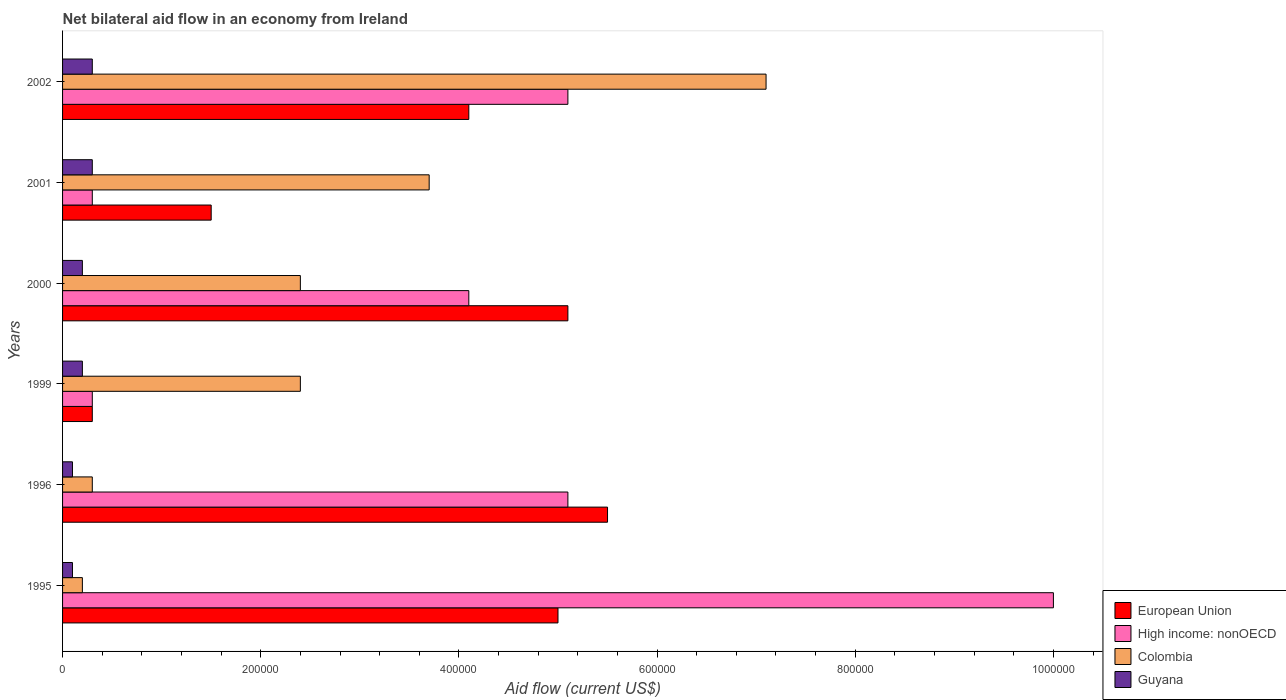How many different coloured bars are there?
Keep it short and to the point. 4. How many groups of bars are there?
Provide a succinct answer. 6. Are the number of bars per tick equal to the number of legend labels?
Ensure brevity in your answer.  Yes. Are the number of bars on each tick of the Y-axis equal?
Make the answer very short. Yes. How many bars are there on the 1st tick from the top?
Offer a terse response. 4. What is the label of the 3rd group of bars from the top?
Make the answer very short. 2000. In how many cases, is the number of bars for a given year not equal to the number of legend labels?
Your answer should be compact. 0. What is the net bilateral aid flow in Colombia in 1995?
Your answer should be very brief. 2.00e+04. Across all years, what is the maximum net bilateral aid flow in European Union?
Make the answer very short. 5.50e+05. Across all years, what is the minimum net bilateral aid flow in Guyana?
Keep it short and to the point. 10000. What is the total net bilateral aid flow in Colombia in the graph?
Your response must be concise. 1.61e+06. What is the difference between the net bilateral aid flow in European Union in 1996 and the net bilateral aid flow in High income: nonOECD in 1995?
Make the answer very short. -4.50e+05. What is the average net bilateral aid flow in European Union per year?
Your answer should be compact. 3.58e+05. In the year 1996, what is the difference between the net bilateral aid flow in Colombia and net bilateral aid flow in European Union?
Ensure brevity in your answer.  -5.20e+05. What is the ratio of the net bilateral aid flow in Guyana in 1999 to that in 2000?
Your response must be concise. 1. Is the difference between the net bilateral aid flow in Colombia in 1995 and 1999 greater than the difference between the net bilateral aid flow in European Union in 1995 and 1999?
Your response must be concise. No. What is the difference between the highest and the second highest net bilateral aid flow in European Union?
Give a very brief answer. 4.00e+04. What is the difference between the highest and the lowest net bilateral aid flow in Guyana?
Give a very brief answer. 2.00e+04. Is the sum of the net bilateral aid flow in European Union in 2000 and 2002 greater than the maximum net bilateral aid flow in High income: nonOECD across all years?
Give a very brief answer. No. Is it the case that in every year, the sum of the net bilateral aid flow in High income: nonOECD and net bilateral aid flow in Colombia is greater than the sum of net bilateral aid flow in European Union and net bilateral aid flow in Guyana?
Provide a short and direct response. No. What does the 4th bar from the bottom in 2002 represents?
Your response must be concise. Guyana. How many bars are there?
Your response must be concise. 24. Are all the bars in the graph horizontal?
Keep it short and to the point. Yes. How many years are there in the graph?
Ensure brevity in your answer.  6. What is the difference between two consecutive major ticks on the X-axis?
Offer a terse response. 2.00e+05. Does the graph contain any zero values?
Your answer should be very brief. No. Does the graph contain grids?
Provide a short and direct response. No. Where does the legend appear in the graph?
Your answer should be very brief. Bottom right. How many legend labels are there?
Give a very brief answer. 4. How are the legend labels stacked?
Make the answer very short. Vertical. What is the title of the graph?
Keep it short and to the point. Net bilateral aid flow in an economy from Ireland. Does "Cyprus" appear as one of the legend labels in the graph?
Make the answer very short. No. What is the label or title of the X-axis?
Keep it short and to the point. Aid flow (current US$). What is the label or title of the Y-axis?
Provide a succinct answer. Years. What is the Aid flow (current US$) in High income: nonOECD in 1995?
Keep it short and to the point. 1.00e+06. What is the Aid flow (current US$) of European Union in 1996?
Give a very brief answer. 5.50e+05. What is the Aid flow (current US$) of High income: nonOECD in 1996?
Make the answer very short. 5.10e+05. What is the Aid flow (current US$) in Colombia in 1996?
Offer a terse response. 3.00e+04. What is the Aid flow (current US$) of Guyana in 1996?
Offer a terse response. 10000. What is the Aid flow (current US$) in High income: nonOECD in 1999?
Your answer should be very brief. 3.00e+04. What is the Aid flow (current US$) in Colombia in 1999?
Keep it short and to the point. 2.40e+05. What is the Aid flow (current US$) of European Union in 2000?
Make the answer very short. 5.10e+05. What is the Aid flow (current US$) of European Union in 2001?
Offer a very short reply. 1.50e+05. What is the Aid flow (current US$) in High income: nonOECD in 2001?
Offer a terse response. 3.00e+04. What is the Aid flow (current US$) in Colombia in 2001?
Your answer should be compact. 3.70e+05. What is the Aid flow (current US$) of Guyana in 2001?
Make the answer very short. 3.00e+04. What is the Aid flow (current US$) of European Union in 2002?
Provide a succinct answer. 4.10e+05. What is the Aid flow (current US$) of High income: nonOECD in 2002?
Your answer should be compact. 5.10e+05. What is the Aid flow (current US$) of Colombia in 2002?
Provide a succinct answer. 7.10e+05. Across all years, what is the maximum Aid flow (current US$) in Colombia?
Give a very brief answer. 7.10e+05. Across all years, what is the maximum Aid flow (current US$) in Guyana?
Keep it short and to the point. 3.00e+04. Across all years, what is the minimum Aid flow (current US$) in Colombia?
Ensure brevity in your answer.  2.00e+04. Across all years, what is the minimum Aid flow (current US$) of Guyana?
Make the answer very short. 10000. What is the total Aid flow (current US$) in European Union in the graph?
Your answer should be very brief. 2.15e+06. What is the total Aid flow (current US$) of High income: nonOECD in the graph?
Give a very brief answer. 2.49e+06. What is the total Aid flow (current US$) in Colombia in the graph?
Your answer should be compact. 1.61e+06. What is the difference between the Aid flow (current US$) in European Union in 1995 and that in 1996?
Offer a terse response. -5.00e+04. What is the difference between the Aid flow (current US$) of Colombia in 1995 and that in 1996?
Your answer should be very brief. -10000. What is the difference between the Aid flow (current US$) of European Union in 1995 and that in 1999?
Offer a terse response. 4.70e+05. What is the difference between the Aid flow (current US$) of High income: nonOECD in 1995 and that in 1999?
Your answer should be very brief. 9.70e+05. What is the difference between the Aid flow (current US$) in Colombia in 1995 and that in 1999?
Make the answer very short. -2.20e+05. What is the difference between the Aid flow (current US$) of Guyana in 1995 and that in 1999?
Provide a succinct answer. -10000. What is the difference between the Aid flow (current US$) of High income: nonOECD in 1995 and that in 2000?
Your answer should be compact. 5.90e+05. What is the difference between the Aid flow (current US$) of Colombia in 1995 and that in 2000?
Make the answer very short. -2.20e+05. What is the difference between the Aid flow (current US$) in High income: nonOECD in 1995 and that in 2001?
Provide a short and direct response. 9.70e+05. What is the difference between the Aid flow (current US$) in Colombia in 1995 and that in 2001?
Keep it short and to the point. -3.50e+05. What is the difference between the Aid flow (current US$) of Guyana in 1995 and that in 2001?
Make the answer very short. -2.00e+04. What is the difference between the Aid flow (current US$) of European Union in 1995 and that in 2002?
Your answer should be very brief. 9.00e+04. What is the difference between the Aid flow (current US$) in High income: nonOECD in 1995 and that in 2002?
Provide a succinct answer. 4.90e+05. What is the difference between the Aid flow (current US$) of Colombia in 1995 and that in 2002?
Make the answer very short. -6.90e+05. What is the difference between the Aid flow (current US$) of Guyana in 1995 and that in 2002?
Your answer should be very brief. -2.00e+04. What is the difference between the Aid flow (current US$) of European Union in 1996 and that in 1999?
Give a very brief answer. 5.20e+05. What is the difference between the Aid flow (current US$) in European Union in 1996 and that in 2000?
Ensure brevity in your answer.  4.00e+04. What is the difference between the Aid flow (current US$) of High income: nonOECD in 1996 and that in 2000?
Offer a terse response. 1.00e+05. What is the difference between the Aid flow (current US$) of European Union in 1996 and that in 2001?
Your answer should be compact. 4.00e+05. What is the difference between the Aid flow (current US$) of High income: nonOECD in 1996 and that in 2001?
Provide a succinct answer. 4.80e+05. What is the difference between the Aid flow (current US$) in Colombia in 1996 and that in 2001?
Offer a terse response. -3.40e+05. What is the difference between the Aid flow (current US$) in European Union in 1996 and that in 2002?
Provide a succinct answer. 1.40e+05. What is the difference between the Aid flow (current US$) of Colombia in 1996 and that in 2002?
Give a very brief answer. -6.80e+05. What is the difference between the Aid flow (current US$) in European Union in 1999 and that in 2000?
Offer a very short reply. -4.80e+05. What is the difference between the Aid flow (current US$) of High income: nonOECD in 1999 and that in 2000?
Offer a very short reply. -3.80e+05. What is the difference between the Aid flow (current US$) of Guyana in 1999 and that in 2000?
Ensure brevity in your answer.  0. What is the difference between the Aid flow (current US$) of Colombia in 1999 and that in 2001?
Make the answer very short. -1.30e+05. What is the difference between the Aid flow (current US$) in European Union in 1999 and that in 2002?
Provide a short and direct response. -3.80e+05. What is the difference between the Aid flow (current US$) of High income: nonOECD in 1999 and that in 2002?
Ensure brevity in your answer.  -4.80e+05. What is the difference between the Aid flow (current US$) in Colombia in 1999 and that in 2002?
Offer a terse response. -4.70e+05. What is the difference between the Aid flow (current US$) in Guyana in 1999 and that in 2002?
Give a very brief answer. -10000. What is the difference between the Aid flow (current US$) in European Union in 2000 and that in 2001?
Your answer should be compact. 3.60e+05. What is the difference between the Aid flow (current US$) in European Union in 2000 and that in 2002?
Your answer should be compact. 1.00e+05. What is the difference between the Aid flow (current US$) in Colombia in 2000 and that in 2002?
Your response must be concise. -4.70e+05. What is the difference between the Aid flow (current US$) of European Union in 2001 and that in 2002?
Provide a short and direct response. -2.60e+05. What is the difference between the Aid flow (current US$) of High income: nonOECD in 2001 and that in 2002?
Offer a terse response. -4.80e+05. What is the difference between the Aid flow (current US$) of European Union in 1995 and the Aid flow (current US$) of High income: nonOECD in 1996?
Keep it short and to the point. -10000. What is the difference between the Aid flow (current US$) of High income: nonOECD in 1995 and the Aid flow (current US$) of Colombia in 1996?
Your response must be concise. 9.70e+05. What is the difference between the Aid flow (current US$) in High income: nonOECD in 1995 and the Aid flow (current US$) in Guyana in 1996?
Offer a terse response. 9.90e+05. What is the difference between the Aid flow (current US$) of European Union in 1995 and the Aid flow (current US$) of High income: nonOECD in 1999?
Give a very brief answer. 4.70e+05. What is the difference between the Aid flow (current US$) in High income: nonOECD in 1995 and the Aid flow (current US$) in Colombia in 1999?
Provide a succinct answer. 7.60e+05. What is the difference between the Aid flow (current US$) in High income: nonOECD in 1995 and the Aid flow (current US$) in Guyana in 1999?
Give a very brief answer. 9.80e+05. What is the difference between the Aid flow (current US$) of Colombia in 1995 and the Aid flow (current US$) of Guyana in 1999?
Your answer should be very brief. 0. What is the difference between the Aid flow (current US$) of European Union in 1995 and the Aid flow (current US$) of High income: nonOECD in 2000?
Provide a succinct answer. 9.00e+04. What is the difference between the Aid flow (current US$) of High income: nonOECD in 1995 and the Aid flow (current US$) of Colombia in 2000?
Keep it short and to the point. 7.60e+05. What is the difference between the Aid flow (current US$) in High income: nonOECD in 1995 and the Aid flow (current US$) in Guyana in 2000?
Give a very brief answer. 9.80e+05. What is the difference between the Aid flow (current US$) in European Union in 1995 and the Aid flow (current US$) in Colombia in 2001?
Give a very brief answer. 1.30e+05. What is the difference between the Aid flow (current US$) in High income: nonOECD in 1995 and the Aid flow (current US$) in Colombia in 2001?
Offer a terse response. 6.30e+05. What is the difference between the Aid flow (current US$) in High income: nonOECD in 1995 and the Aid flow (current US$) in Guyana in 2001?
Ensure brevity in your answer.  9.70e+05. What is the difference between the Aid flow (current US$) in Colombia in 1995 and the Aid flow (current US$) in Guyana in 2001?
Keep it short and to the point. -10000. What is the difference between the Aid flow (current US$) of European Union in 1995 and the Aid flow (current US$) of Colombia in 2002?
Your answer should be compact. -2.10e+05. What is the difference between the Aid flow (current US$) in European Union in 1995 and the Aid flow (current US$) in Guyana in 2002?
Your answer should be very brief. 4.70e+05. What is the difference between the Aid flow (current US$) of High income: nonOECD in 1995 and the Aid flow (current US$) of Colombia in 2002?
Your answer should be very brief. 2.90e+05. What is the difference between the Aid flow (current US$) of High income: nonOECD in 1995 and the Aid flow (current US$) of Guyana in 2002?
Give a very brief answer. 9.70e+05. What is the difference between the Aid flow (current US$) in Colombia in 1995 and the Aid flow (current US$) in Guyana in 2002?
Ensure brevity in your answer.  -10000. What is the difference between the Aid flow (current US$) of European Union in 1996 and the Aid flow (current US$) of High income: nonOECD in 1999?
Provide a short and direct response. 5.20e+05. What is the difference between the Aid flow (current US$) of European Union in 1996 and the Aid flow (current US$) of Guyana in 1999?
Ensure brevity in your answer.  5.30e+05. What is the difference between the Aid flow (current US$) of High income: nonOECD in 1996 and the Aid flow (current US$) of Guyana in 1999?
Your answer should be very brief. 4.90e+05. What is the difference between the Aid flow (current US$) in European Union in 1996 and the Aid flow (current US$) in High income: nonOECD in 2000?
Ensure brevity in your answer.  1.40e+05. What is the difference between the Aid flow (current US$) of European Union in 1996 and the Aid flow (current US$) of Colombia in 2000?
Make the answer very short. 3.10e+05. What is the difference between the Aid flow (current US$) of European Union in 1996 and the Aid flow (current US$) of Guyana in 2000?
Your response must be concise. 5.30e+05. What is the difference between the Aid flow (current US$) in High income: nonOECD in 1996 and the Aid flow (current US$) in Guyana in 2000?
Your answer should be very brief. 4.90e+05. What is the difference between the Aid flow (current US$) in European Union in 1996 and the Aid flow (current US$) in High income: nonOECD in 2001?
Keep it short and to the point. 5.20e+05. What is the difference between the Aid flow (current US$) in European Union in 1996 and the Aid flow (current US$) in Guyana in 2001?
Offer a terse response. 5.20e+05. What is the difference between the Aid flow (current US$) in High income: nonOECD in 1996 and the Aid flow (current US$) in Guyana in 2001?
Your answer should be very brief. 4.80e+05. What is the difference between the Aid flow (current US$) of Colombia in 1996 and the Aid flow (current US$) of Guyana in 2001?
Your answer should be compact. 0. What is the difference between the Aid flow (current US$) in European Union in 1996 and the Aid flow (current US$) in High income: nonOECD in 2002?
Ensure brevity in your answer.  4.00e+04. What is the difference between the Aid flow (current US$) of European Union in 1996 and the Aid flow (current US$) of Guyana in 2002?
Provide a succinct answer. 5.20e+05. What is the difference between the Aid flow (current US$) of High income: nonOECD in 1996 and the Aid flow (current US$) of Guyana in 2002?
Provide a succinct answer. 4.80e+05. What is the difference between the Aid flow (current US$) of European Union in 1999 and the Aid flow (current US$) of High income: nonOECD in 2000?
Offer a terse response. -3.80e+05. What is the difference between the Aid flow (current US$) in European Union in 1999 and the Aid flow (current US$) in Guyana in 2000?
Your answer should be compact. 10000. What is the difference between the Aid flow (current US$) in High income: nonOECD in 1999 and the Aid flow (current US$) in Colombia in 2000?
Keep it short and to the point. -2.10e+05. What is the difference between the Aid flow (current US$) in High income: nonOECD in 1999 and the Aid flow (current US$) in Guyana in 2000?
Provide a succinct answer. 10000. What is the difference between the Aid flow (current US$) in High income: nonOECD in 1999 and the Aid flow (current US$) in Colombia in 2001?
Give a very brief answer. -3.40e+05. What is the difference between the Aid flow (current US$) of High income: nonOECD in 1999 and the Aid flow (current US$) of Guyana in 2001?
Ensure brevity in your answer.  0. What is the difference between the Aid flow (current US$) in Colombia in 1999 and the Aid flow (current US$) in Guyana in 2001?
Give a very brief answer. 2.10e+05. What is the difference between the Aid flow (current US$) of European Union in 1999 and the Aid flow (current US$) of High income: nonOECD in 2002?
Your response must be concise. -4.80e+05. What is the difference between the Aid flow (current US$) in European Union in 1999 and the Aid flow (current US$) in Colombia in 2002?
Your answer should be compact. -6.80e+05. What is the difference between the Aid flow (current US$) in High income: nonOECD in 1999 and the Aid flow (current US$) in Colombia in 2002?
Offer a very short reply. -6.80e+05. What is the difference between the Aid flow (current US$) in High income: nonOECD in 1999 and the Aid flow (current US$) in Guyana in 2002?
Make the answer very short. 0. What is the difference between the Aid flow (current US$) of European Union in 2000 and the Aid flow (current US$) of High income: nonOECD in 2001?
Provide a short and direct response. 4.80e+05. What is the difference between the Aid flow (current US$) in Colombia in 2000 and the Aid flow (current US$) in Guyana in 2001?
Make the answer very short. 2.10e+05. What is the difference between the Aid flow (current US$) of High income: nonOECD in 2000 and the Aid flow (current US$) of Colombia in 2002?
Give a very brief answer. -3.00e+05. What is the difference between the Aid flow (current US$) in High income: nonOECD in 2000 and the Aid flow (current US$) in Guyana in 2002?
Keep it short and to the point. 3.80e+05. What is the difference between the Aid flow (current US$) in Colombia in 2000 and the Aid flow (current US$) in Guyana in 2002?
Offer a very short reply. 2.10e+05. What is the difference between the Aid flow (current US$) in European Union in 2001 and the Aid flow (current US$) in High income: nonOECD in 2002?
Your answer should be compact. -3.60e+05. What is the difference between the Aid flow (current US$) of European Union in 2001 and the Aid flow (current US$) of Colombia in 2002?
Your answer should be compact. -5.60e+05. What is the difference between the Aid flow (current US$) of High income: nonOECD in 2001 and the Aid flow (current US$) of Colombia in 2002?
Offer a very short reply. -6.80e+05. What is the difference between the Aid flow (current US$) in High income: nonOECD in 2001 and the Aid flow (current US$) in Guyana in 2002?
Provide a succinct answer. 0. What is the average Aid flow (current US$) of European Union per year?
Make the answer very short. 3.58e+05. What is the average Aid flow (current US$) in High income: nonOECD per year?
Provide a succinct answer. 4.15e+05. What is the average Aid flow (current US$) of Colombia per year?
Offer a very short reply. 2.68e+05. In the year 1995, what is the difference between the Aid flow (current US$) in European Union and Aid flow (current US$) in High income: nonOECD?
Offer a terse response. -5.00e+05. In the year 1995, what is the difference between the Aid flow (current US$) of European Union and Aid flow (current US$) of Guyana?
Provide a short and direct response. 4.90e+05. In the year 1995, what is the difference between the Aid flow (current US$) of High income: nonOECD and Aid flow (current US$) of Colombia?
Keep it short and to the point. 9.80e+05. In the year 1995, what is the difference between the Aid flow (current US$) in High income: nonOECD and Aid flow (current US$) in Guyana?
Offer a terse response. 9.90e+05. In the year 1995, what is the difference between the Aid flow (current US$) of Colombia and Aid flow (current US$) of Guyana?
Your response must be concise. 10000. In the year 1996, what is the difference between the Aid flow (current US$) of European Union and Aid flow (current US$) of Colombia?
Provide a succinct answer. 5.20e+05. In the year 1996, what is the difference between the Aid flow (current US$) of European Union and Aid flow (current US$) of Guyana?
Give a very brief answer. 5.40e+05. In the year 1996, what is the difference between the Aid flow (current US$) in Colombia and Aid flow (current US$) in Guyana?
Your answer should be compact. 2.00e+04. In the year 1999, what is the difference between the Aid flow (current US$) of European Union and Aid flow (current US$) of Colombia?
Provide a succinct answer. -2.10e+05. In the year 2000, what is the difference between the Aid flow (current US$) of Colombia and Aid flow (current US$) of Guyana?
Ensure brevity in your answer.  2.20e+05. In the year 2001, what is the difference between the Aid flow (current US$) of European Union and Aid flow (current US$) of High income: nonOECD?
Make the answer very short. 1.20e+05. In the year 2001, what is the difference between the Aid flow (current US$) of High income: nonOECD and Aid flow (current US$) of Colombia?
Give a very brief answer. -3.40e+05. In the year 2001, what is the difference between the Aid flow (current US$) of High income: nonOECD and Aid flow (current US$) of Guyana?
Give a very brief answer. 0. In the year 2001, what is the difference between the Aid flow (current US$) in Colombia and Aid flow (current US$) in Guyana?
Your response must be concise. 3.40e+05. In the year 2002, what is the difference between the Aid flow (current US$) in European Union and Aid flow (current US$) in Guyana?
Provide a short and direct response. 3.80e+05. In the year 2002, what is the difference between the Aid flow (current US$) of Colombia and Aid flow (current US$) of Guyana?
Provide a succinct answer. 6.80e+05. What is the ratio of the Aid flow (current US$) of High income: nonOECD in 1995 to that in 1996?
Provide a succinct answer. 1.96. What is the ratio of the Aid flow (current US$) of Colombia in 1995 to that in 1996?
Keep it short and to the point. 0.67. What is the ratio of the Aid flow (current US$) in European Union in 1995 to that in 1999?
Provide a short and direct response. 16.67. What is the ratio of the Aid flow (current US$) of High income: nonOECD in 1995 to that in 1999?
Give a very brief answer. 33.33. What is the ratio of the Aid flow (current US$) of Colombia in 1995 to that in 1999?
Provide a succinct answer. 0.08. What is the ratio of the Aid flow (current US$) in European Union in 1995 to that in 2000?
Provide a short and direct response. 0.98. What is the ratio of the Aid flow (current US$) in High income: nonOECD in 1995 to that in 2000?
Keep it short and to the point. 2.44. What is the ratio of the Aid flow (current US$) of Colombia in 1995 to that in 2000?
Offer a very short reply. 0.08. What is the ratio of the Aid flow (current US$) in High income: nonOECD in 1995 to that in 2001?
Provide a succinct answer. 33.33. What is the ratio of the Aid flow (current US$) of Colombia in 1995 to that in 2001?
Your answer should be compact. 0.05. What is the ratio of the Aid flow (current US$) of European Union in 1995 to that in 2002?
Your answer should be very brief. 1.22. What is the ratio of the Aid flow (current US$) of High income: nonOECD in 1995 to that in 2002?
Provide a short and direct response. 1.96. What is the ratio of the Aid flow (current US$) of Colombia in 1995 to that in 2002?
Provide a short and direct response. 0.03. What is the ratio of the Aid flow (current US$) of European Union in 1996 to that in 1999?
Give a very brief answer. 18.33. What is the ratio of the Aid flow (current US$) in European Union in 1996 to that in 2000?
Provide a succinct answer. 1.08. What is the ratio of the Aid flow (current US$) in High income: nonOECD in 1996 to that in 2000?
Ensure brevity in your answer.  1.24. What is the ratio of the Aid flow (current US$) of Colombia in 1996 to that in 2000?
Your response must be concise. 0.12. What is the ratio of the Aid flow (current US$) of European Union in 1996 to that in 2001?
Give a very brief answer. 3.67. What is the ratio of the Aid flow (current US$) of Colombia in 1996 to that in 2001?
Your response must be concise. 0.08. What is the ratio of the Aid flow (current US$) of Guyana in 1996 to that in 2001?
Make the answer very short. 0.33. What is the ratio of the Aid flow (current US$) in European Union in 1996 to that in 2002?
Your answer should be compact. 1.34. What is the ratio of the Aid flow (current US$) in Colombia in 1996 to that in 2002?
Ensure brevity in your answer.  0.04. What is the ratio of the Aid flow (current US$) of European Union in 1999 to that in 2000?
Your answer should be compact. 0.06. What is the ratio of the Aid flow (current US$) in High income: nonOECD in 1999 to that in 2000?
Keep it short and to the point. 0.07. What is the ratio of the Aid flow (current US$) of Guyana in 1999 to that in 2000?
Ensure brevity in your answer.  1. What is the ratio of the Aid flow (current US$) of Colombia in 1999 to that in 2001?
Offer a terse response. 0.65. What is the ratio of the Aid flow (current US$) of European Union in 1999 to that in 2002?
Make the answer very short. 0.07. What is the ratio of the Aid flow (current US$) of High income: nonOECD in 1999 to that in 2002?
Provide a short and direct response. 0.06. What is the ratio of the Aid flow (current US$) of Colombia in 1999 to that in 2002?
Keep it short and to the point. 0.34. What is the ratio of the Aid flow (current US$) in Guyana in 1999 to that in 2002?
Offer a terse response. 0.67. What is the ratio of the Aid flow (current US$) in High income: nonOECD in 2000 to that in 2001?
Your answer should be compact. 13.67. What is the ratio of the Aid flow (current US$) of Colombia in 2000 to that in 2001?
Keep it short and to the point. 0.65. What is the ratio of the Aid flow (current US$) in European Union in 2000 to that in 2002?
Ensure brevity in your answer.  1.24. What is the ratio of the Aid flow (current US$) in High income: nonOECD in 2000 to that in 2002?
Provide a short and direct response. 0.8. What is the ratio of the Aid flow (current US$) of Colombia in 2000 to that in 2002?
Give a very brief answer. 0.34. What is the ratio of the Aid flow (current US$) of European Union in 2001 to that in 2002?
Provide a short and direct response. 0.37. What is the ratio of the Aid flow (current US$) of High income: nonOECD in 2001 to that in 2002?
Give a very brief answer. 0.06. What is the ratio of the Aid flow (current US$) in Colombia in 2001 to that in 2002?
Your answer should be compact. 0.52. What is the ratio of the Aid flow (current US$) in Guyana in 2001 to that in 2002?
Make the answer very short. 1. What is the difference between the highest and the second highest Aid flow (current US$) in European Union?
Ensure brevity in your answer.  4.00e+04. What is the difference between the highest and the second highest Aid flow (current US$) of Colombia?
Your response must be concise. 3.40e+05. What is the difference between the highest and the second highest Aid flow (current US$) in Guyana?
Provide a short and direct response. 0. What is the difference between the highest and the lowest Aid flow (current US$) in European Union?
Provide a succinct answer. 5.20e+05. What is the difference between the highest and the lowest Aid flow (current US$) of High income: nonOECD?
Make the answer very short. 9.70e+05. What is the difference between the highest and the lowest Aid flow (current US$) of Colombia?
Your answer should be compact. 6.90e+05. 